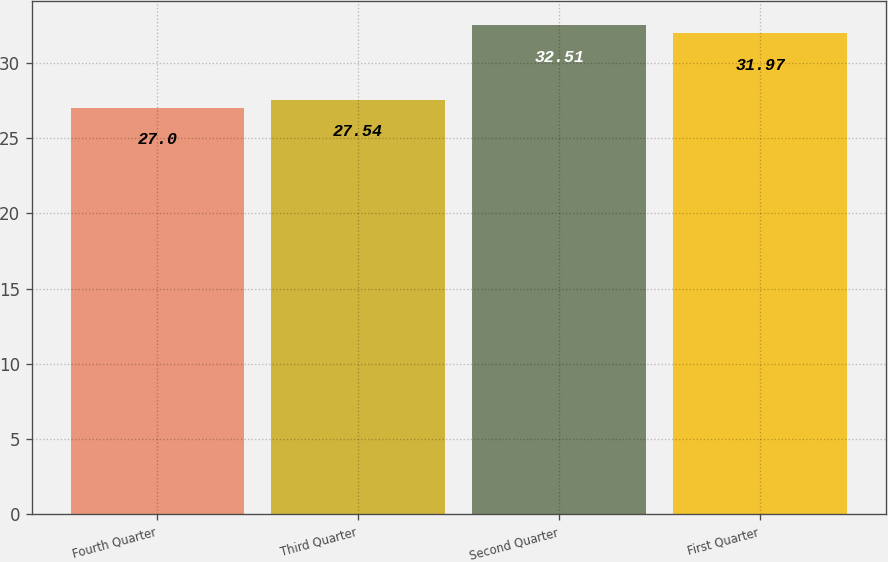Convert chart. <chart><loc_0><loc_0><loc_500><loc_500><bar_chart><fcel>Fourth Quarter<fcel>Third Quarter<fcel>Second Quarter<fcel>First Quarter<nl><fcel>27<fcel>27.54<fcel>32.51<fcel>31.97<nl></chart> 